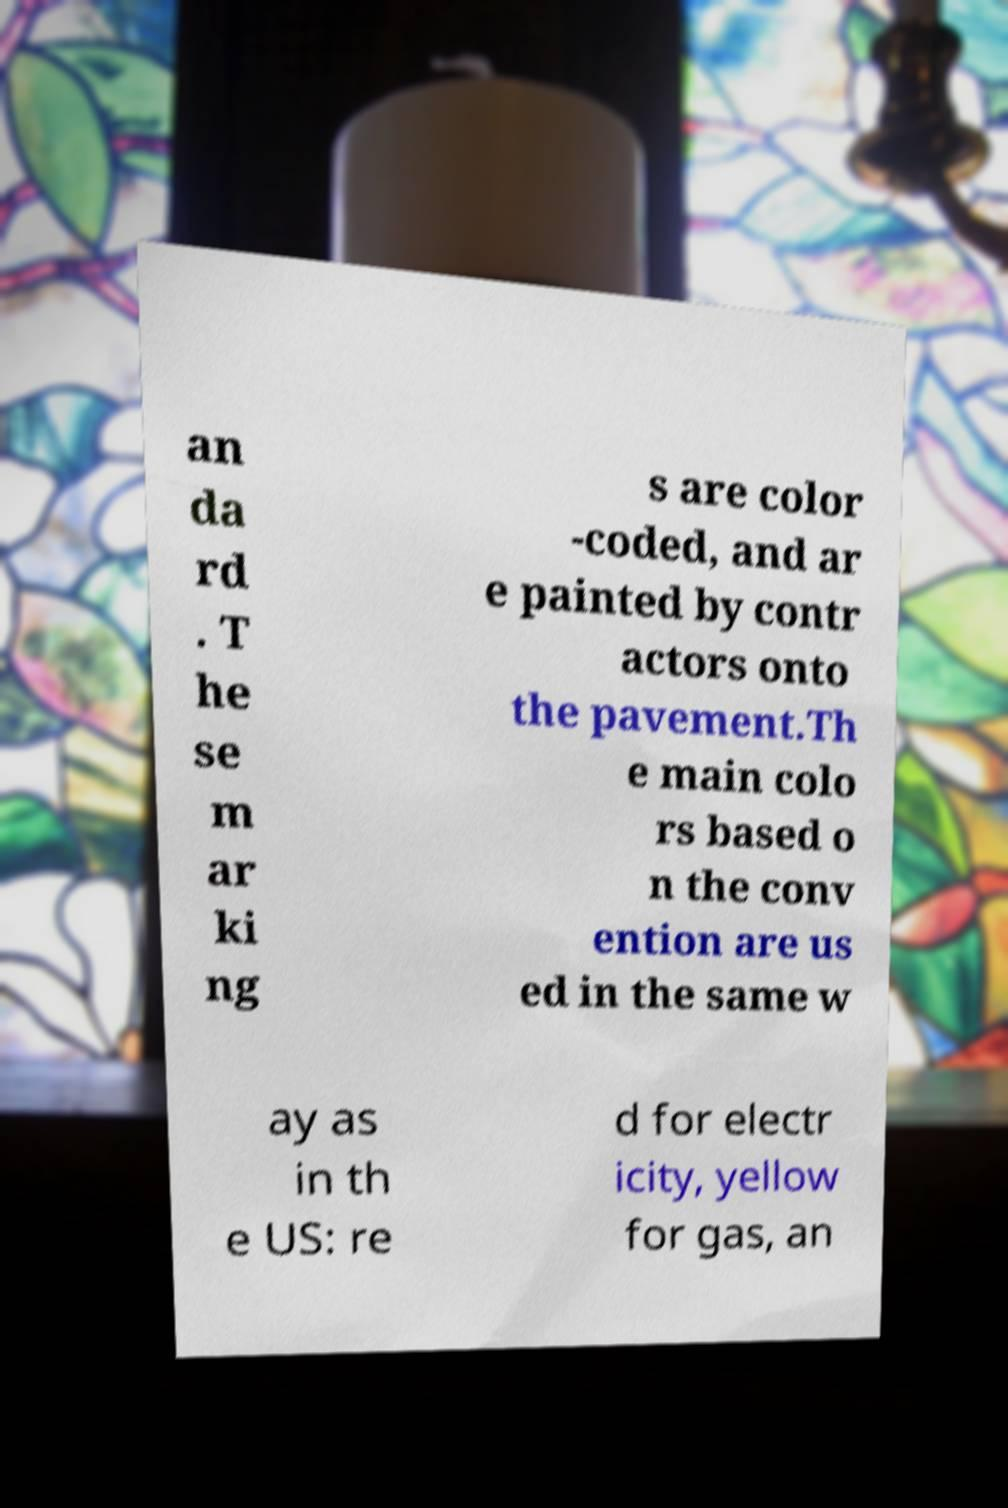Could you extract and type out the text from this image? an da rd . T he se m ar ki ng s are color -coded, and ar e painted by contr actors onto the pavement.Th e main colo rs based o n the conv ention are us ed in the same w ay as in th e US: re d for electr icity, yellow for gas, an 